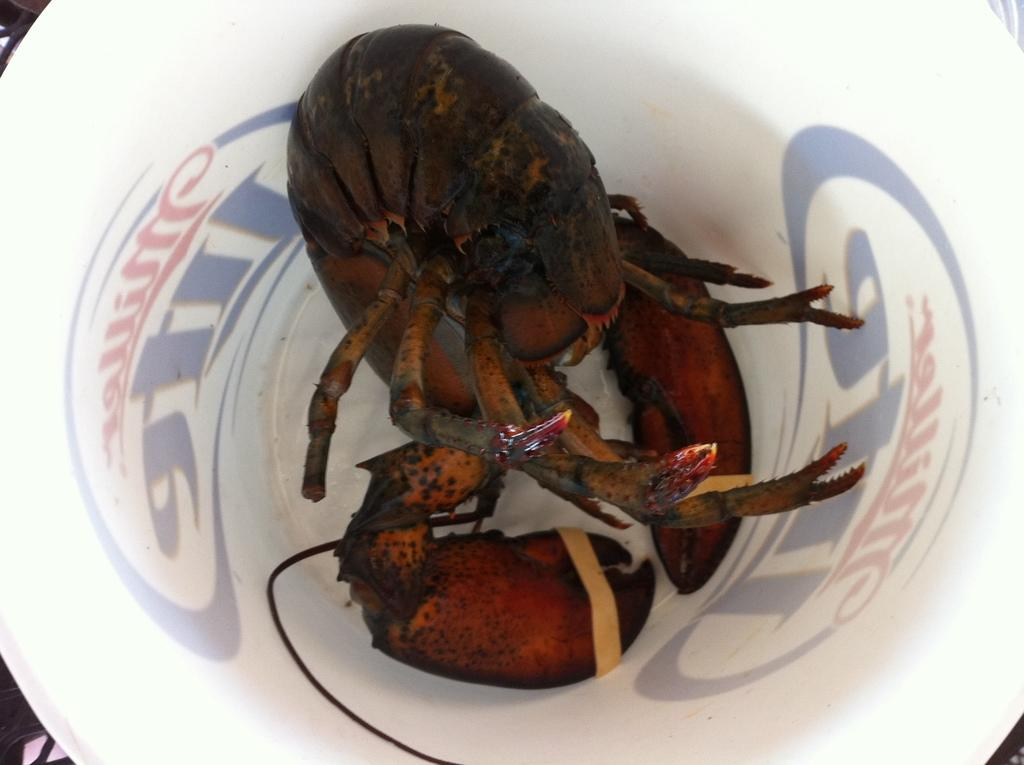What type of seafood is present in the image? There are crabs in a bowl in the image. What is the container holding the crabs? The crabs are in a bowl. Are there any additional elements around the bowl? Yes, there are texts around the bowl in the image. How many geese are swimming in the jar in the image? There are no geese or jars present in the image. 